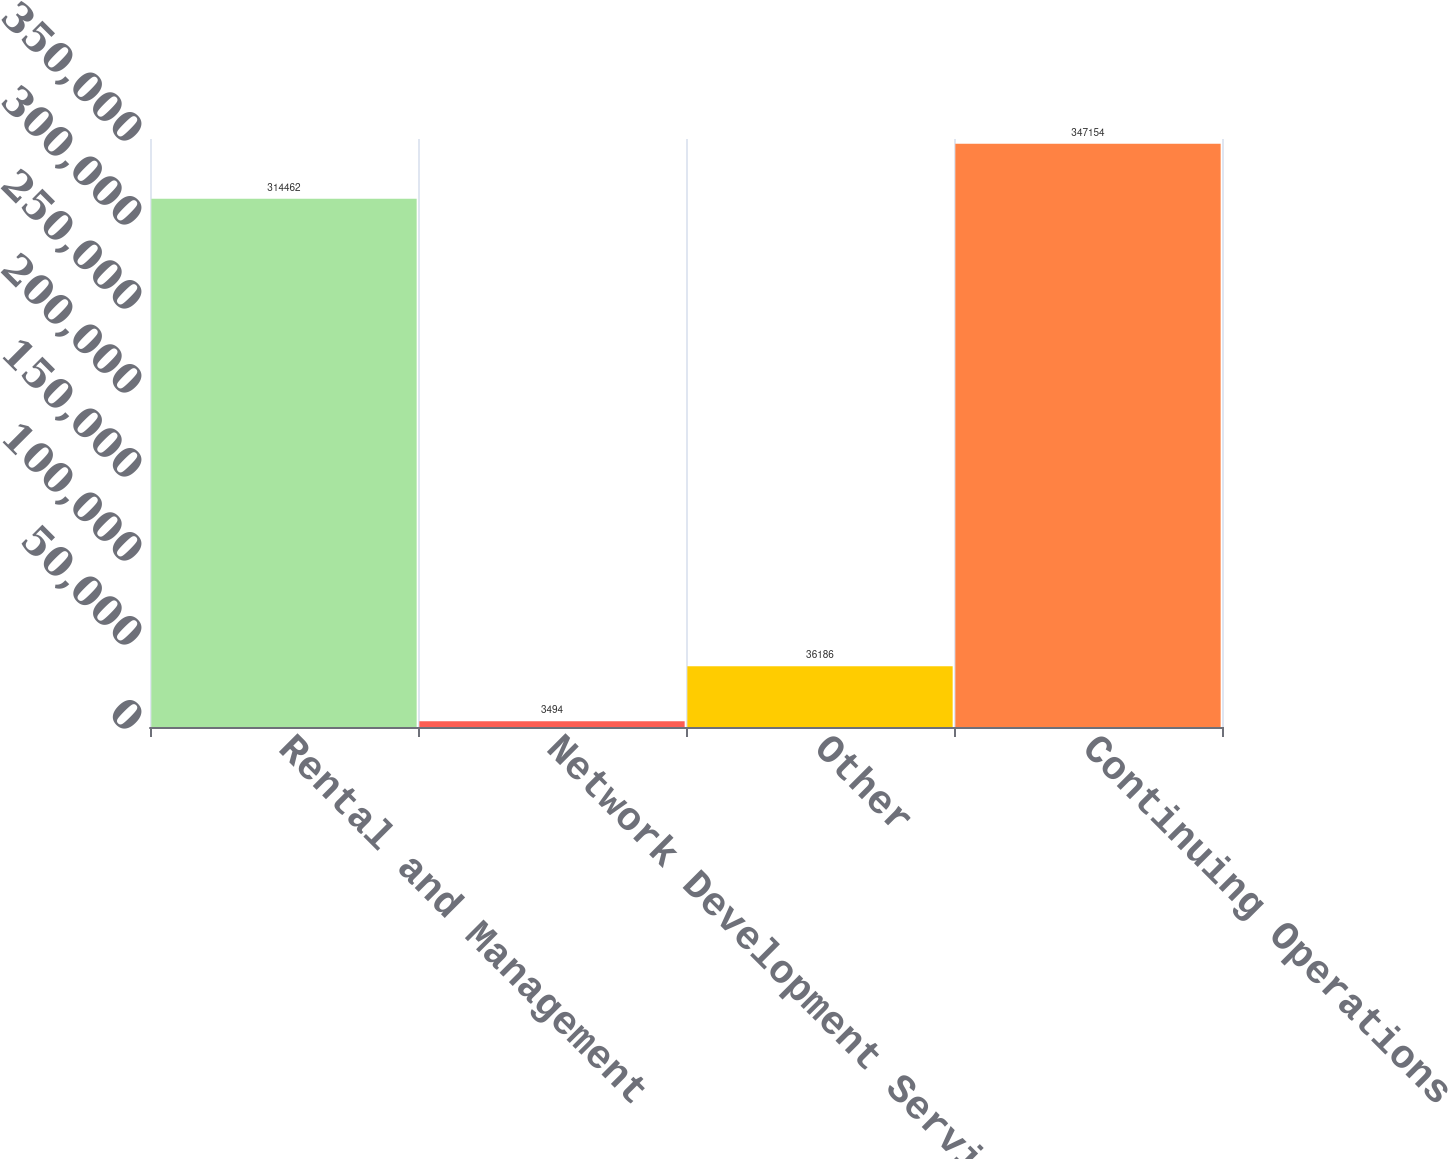Convert chart to OTSL. <chart><loc_0><loc_0><loc_500><loc_500><bar_chart><fcel>Rental and Management<fcel>Network Development Services<fcel>Other<fcel>Continuing Operations<nl><fcel>314462<fcel>3494<fcel>36186<fcel>347154<nl></chart> 